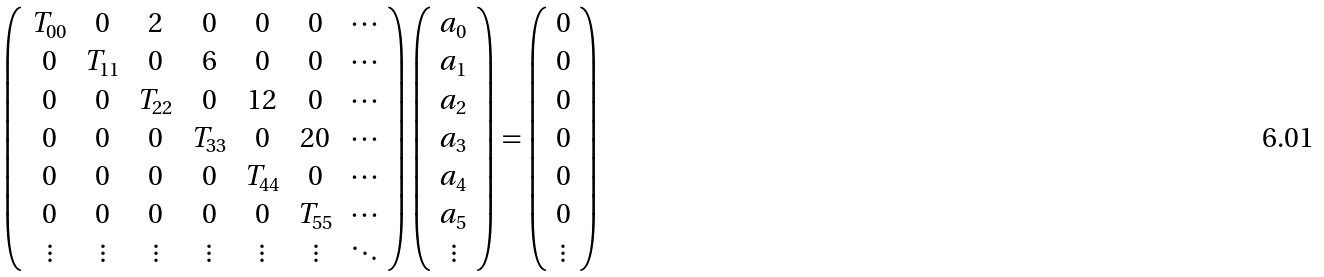<formula> <loc_0><loc_0><loc_500><loc_500>\left ( \begin{array} { c c c c c c c } T _ { 0 0 } & 0 & 2 & 0 & 0 & 0 & \cdots \\ 0 & T _ { 1 1 } & 0 & 6 & 0 & 0 & \cdots \\ 0 & 0 & T _ { 2 2 } & 0 & 1 2 & 0 & \cdots \\ 0 & 0 & 0 & T _ { 3 3 } & 0 & 2 0 & \cdots \\ 0 & 0 & 0 & 0 & T _ { 4 4 } & 0 & \cdots \\ 0 & 0 & 0 & 0 & 0 & T _ { 5 5 } & \cdots \\ \vdots & \vdots & \vdots & \vdots & \vdots & \vdots & \ddots \end{array} \right ) \left ( \begin{array} { c } a _ { 0 } \\ a _ { 1 } \\ a _ { 2 } \\ a _ { 3 } \\ a _ { 4 } \\ a _ { 5 } \\ \vdots \end{array} \right ) = \left ( \begin{array} { c } 0 \\ 0 \\ 0 \\ 0 \\ 0 \\ 0 \\ \vdots \end{array} \right )</formula> 